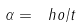Convert formula to latex. <formula><loc_0><loc_0><loc_500><loc_500>\alpha = \ h o / t</formula> 